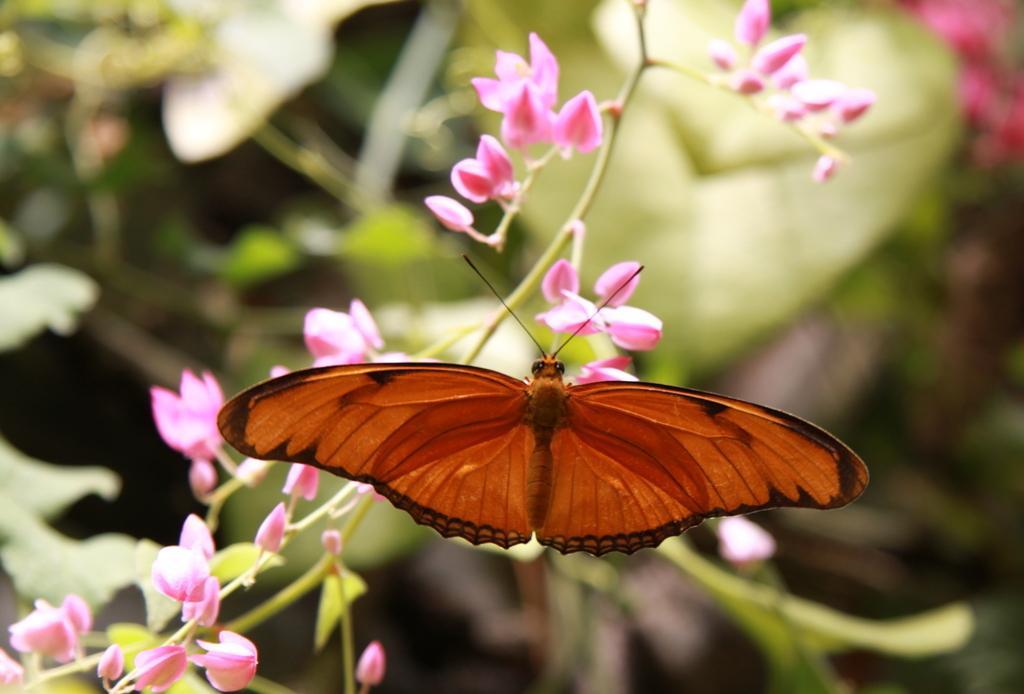Could you give a brief overview of what you see in this image? In this picture we can see flowers and a butterfly in the middle of the image, we can see blurry background. 